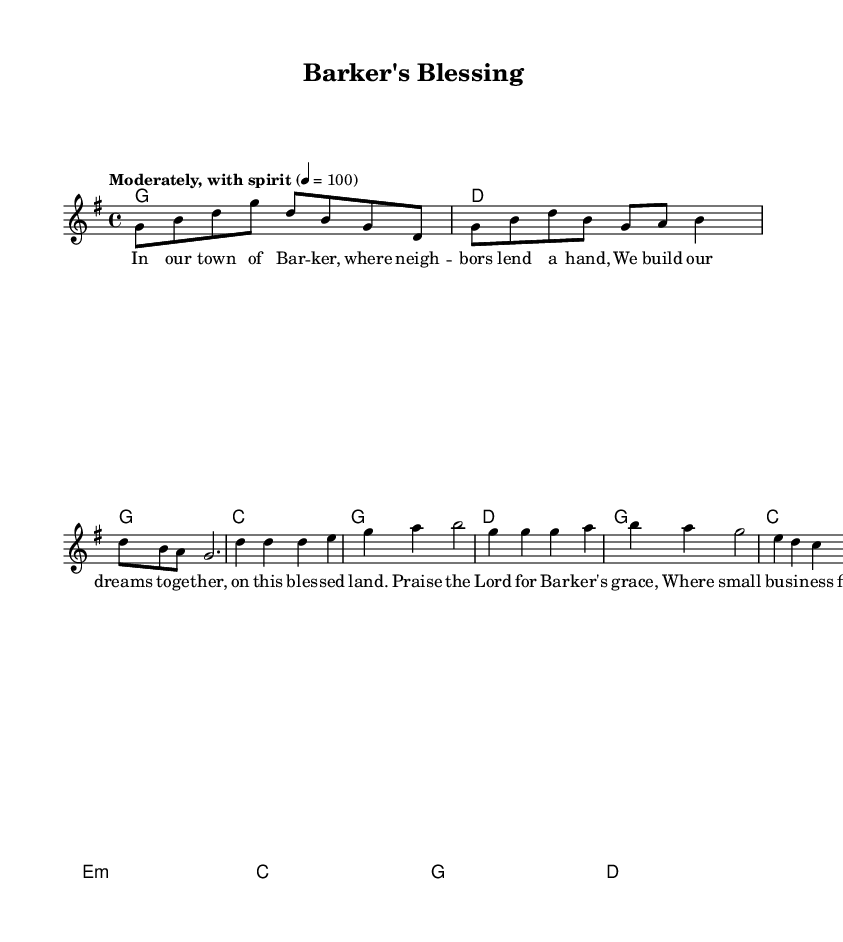What is the key signature of this music? The key signature is G major, which has one sharp (F#).
Answer: G major What is the time signature of this music? The time signature is 4/4, indicating four beats per measure.
Answer: 4/4 What is the tempo marking of this piece? The tempo marking is "Moderately, with spirit," suggesting a lively pace.
Answer: Moderately, with spirit What chord is played in the introduction? The introduction starts with a G major chord, which is denoted by the letter G.
Answer: G How many verses are present in this piece? There are two verses present, as indicated by the two separate sections labeled "verseOne" and "verseTwo."
Answer: Two What is the theme emphasized in the chorus? The theme emphasized in the chorus is the grace of Barker and small business importance, expressed as "Praise the Lord for Barker's grace."
Answer: Grace of Barker What is the main message found in the bridge? The main message in the bridge is about unity and seeking divine guidance, shown through the lines "United in council, we stand strong and true."
Answer: Unity and guidance 